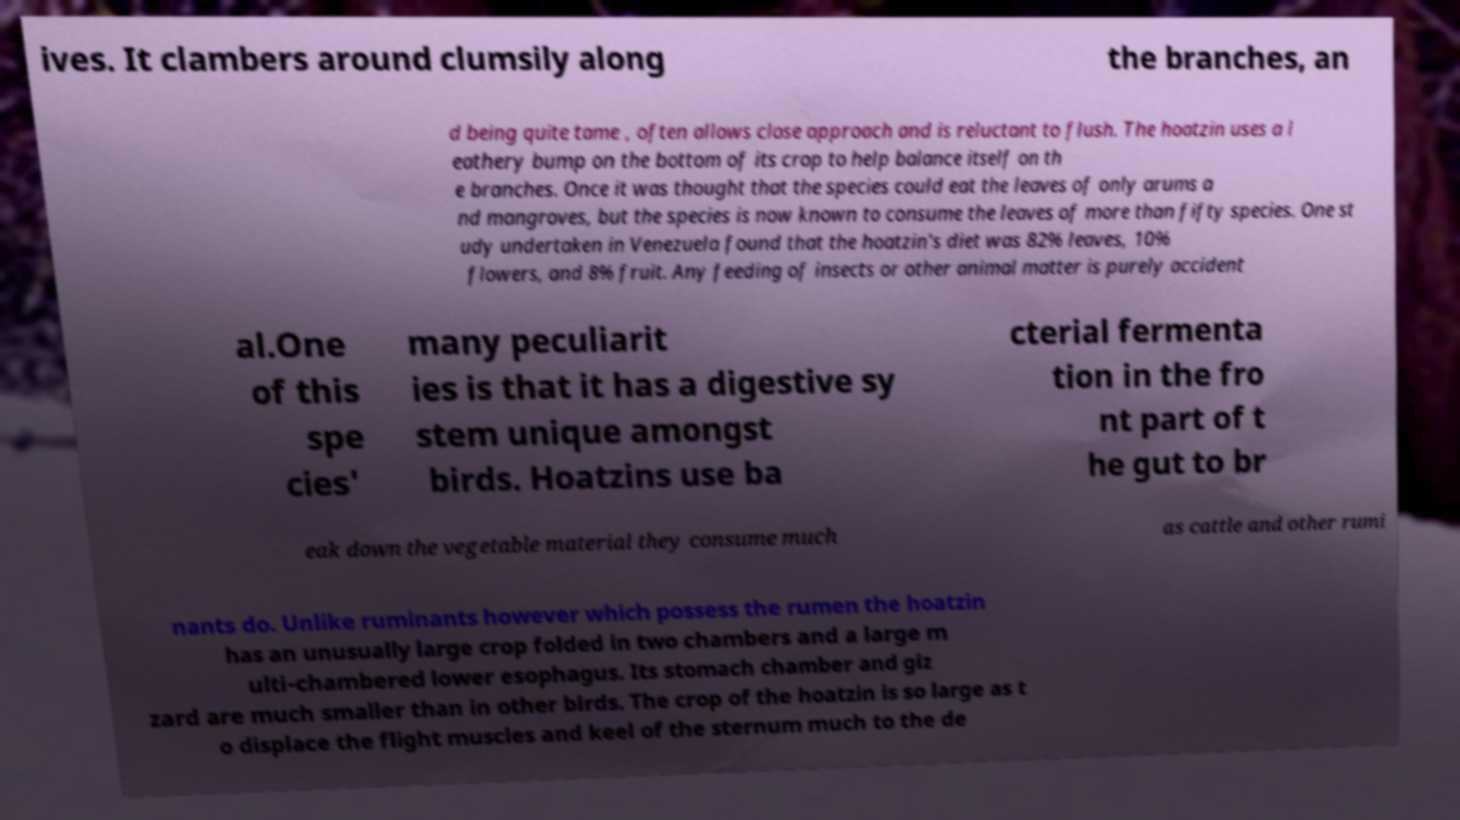What messages or text are displayed in this image? I need them in a readable, typed format. ives. It clambers around clumsily along the branches, an d being quite tame , often allows close approach and is reluctant to flush. The hoatzin uses a l eathery bump on the bottom of its crop to help balance itself on th e branches. Once it was thought that the species could eat the leaves of only arums a nd mangroves, but the species is now known to consume the leaves of more than fifty species. One st udy undertaken in Venezuela found that the hoatzin's diet was 82% leaves, 10% flowers, and 8% fruit. Any feeding of insects or other animal matter is purely accident al.One of this spe cies' many peculiarit ies is that it has a digestive sy stem unique amongst birds. Hoatzins use ba cterial fermenta tion in the fro nt part of t he gut to br eak down the vegetable material they consume much as cattle and other rumi nants do. Unlike ruminants however which possess the rumen the hoatzin has an unusually large crop folded in two chambers and a large m ulti-chambered lower esophagus. Its stomach chamber and giz zard are much smaller than in other birds. The crop of the hoatzin is so large as t o displace the flight muscles and keel of the sternum much to the de 